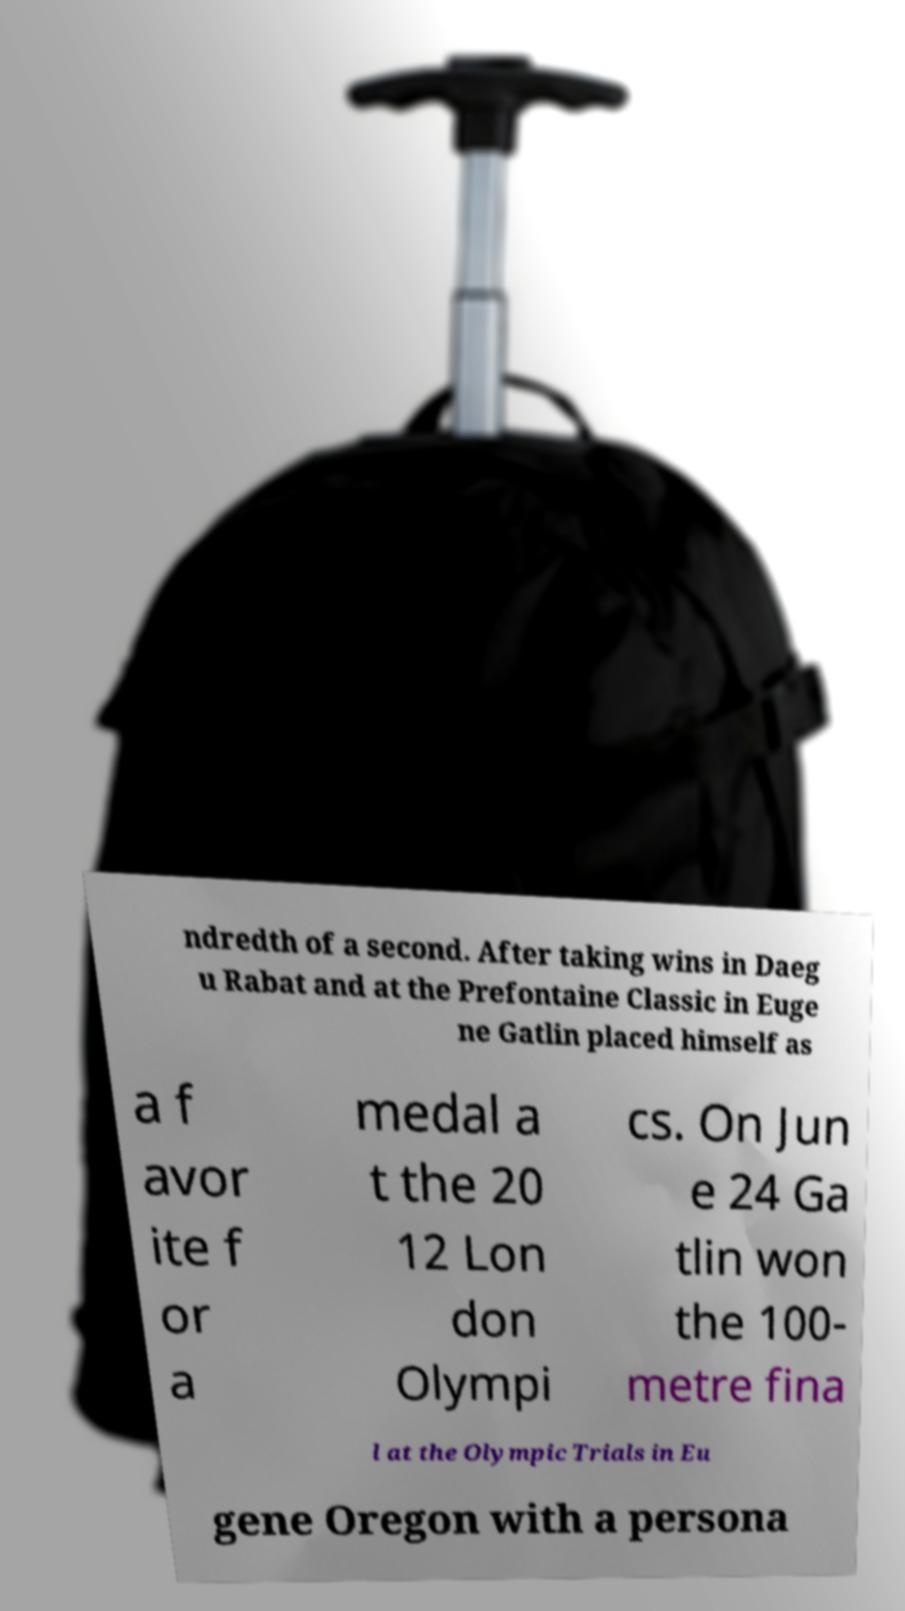For documentation purposes, I need the text within this image transcribed. Could you provide that? ndredth of a second. After taking wins in Daeg u Rabat and at the Prefontaine Classic in Euge ne Gatlin placed himself as a f avor ite f or a medal a t the 20 12 Lon don Olympi cs. On Jun e 24 Ga tlin won the 100- metre fina l at the Olympic Trials in Eu gene Oregon with a persona 